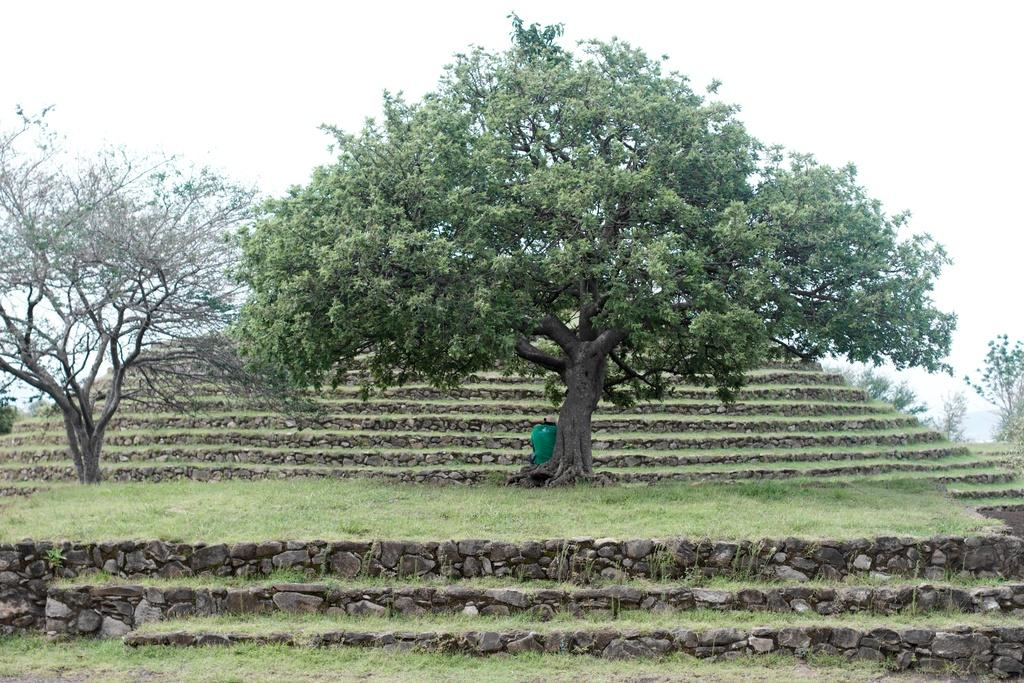What type of natural elements can be seen in the image? There are trees in the image. What architectural feature is present in the image? There are steps in the middle of the image. What can be seen in the background of the image? There is a sky visible in the background of the image. How many beds can be seen in the image? There are no beds present in the image. What type of shock is visible in the image? There is no shock visible in the image. 